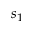Convert formula to latex. <formula><loc_0><loc_0><loc_500><loc_500>s _ { 1 }</formula> 